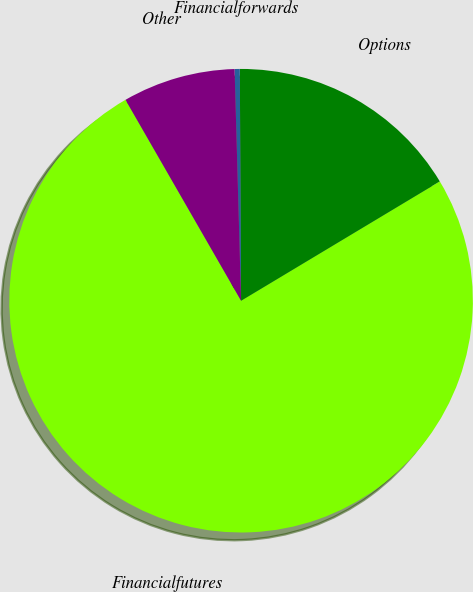Convert chart. <chart><loc_0><loc_0><loc_500><loc_500><pie_chart><fcel>Financialfutures<fcel>Options<fcel>Financialforwards<fcel>Other<nl><fcel>75.3%<fcel>16.48%<fcel>0.36%<fcel>7.86%<nl></chart> 